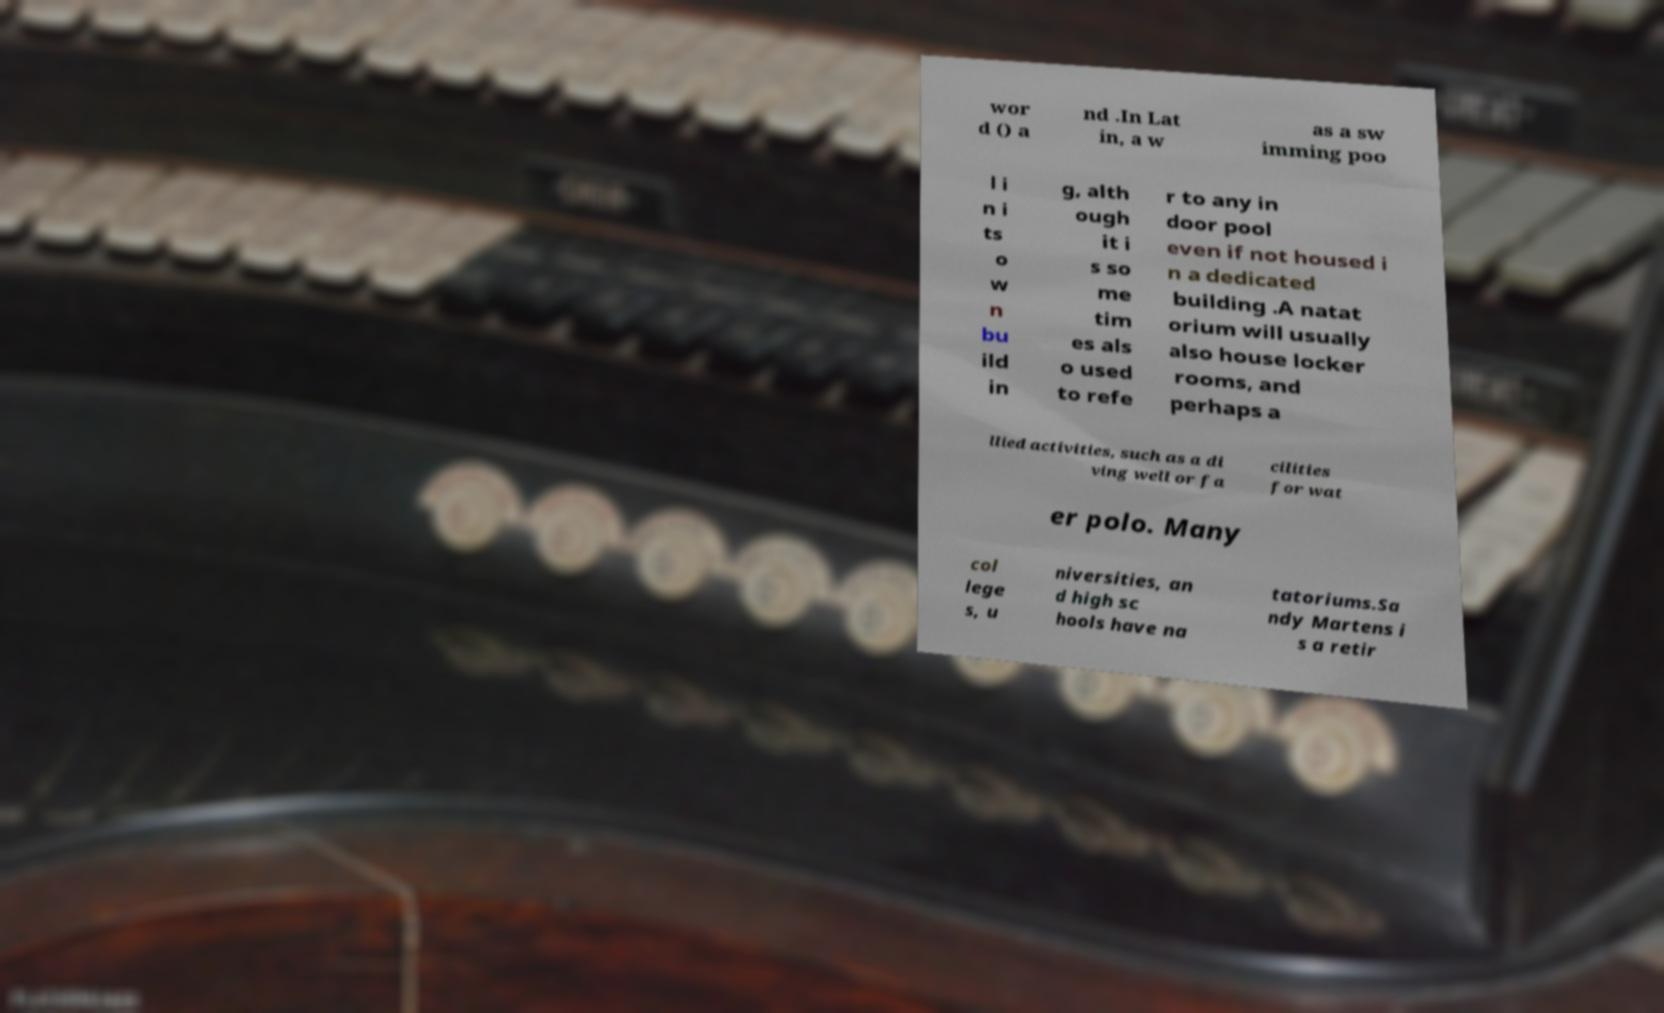What messages or text are displayed in this image? I need them in a readable, typed format. wor d () a nd .In Lat in, a w as a sw imming poo l i n i ts o w n bu ild in g, alth ough it i s so me tim es als o used to refe r to any in door pool even if not housed i n a dedicated building .A natat orium will usually also house locker rooms, and perhaps a llied activities, such as a di ving well or fa cilities for wat er polo. Many col lege s, u niversities, an d high sc hools have na tatoriums.Sa ndy Martens i s a retir 